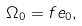<formula> <loc_0><loc_0><loc_500><loc_500>\Omega _ { 0 } = f e _ { 0 } ,</formula> 